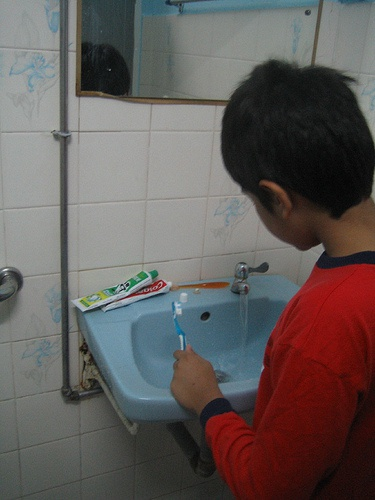Describe the objects in this image and their specific colors. I can see people in darkgray, black, and maroon tones, sink in darkgray, gray, and blue tones, toothbrush in darkgray, teal, and gray tones, and toothbrush in darkgray, maroon, and gray tones in this image. 